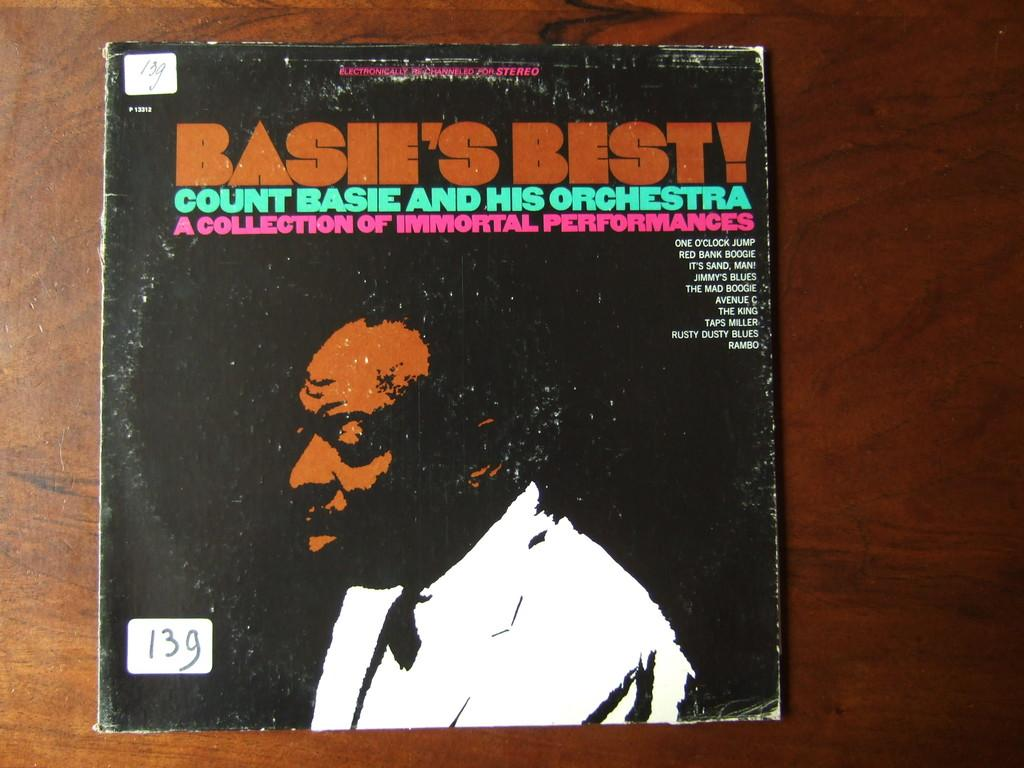<image>
Summarize the visual content of the image. An album by Count Basie and his orchestra is numbered 139 on a small white sticker. 